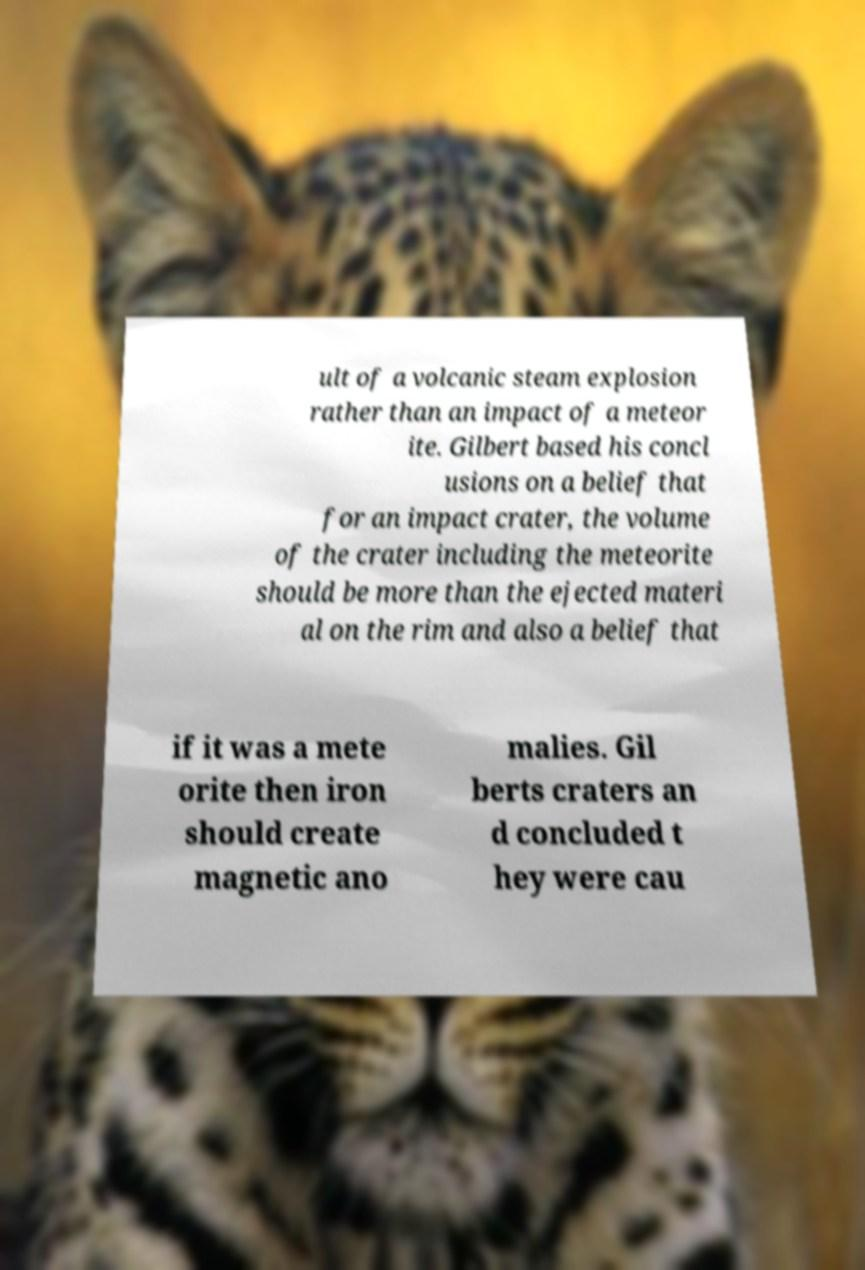Can you accurately transcribe the text from the provided image for me? ult of a volcanic steam explosion rather than an impact of a meteor ite. Gilbert based his concl usions on a belief that for an impact crater, the volume of the crater including the meteorite should be more than the ejected materi al on the rim and also a belief that if it was a mete orite then iron should create magnetic ano malies. Gil berts craters an d concluded t hey were cau 